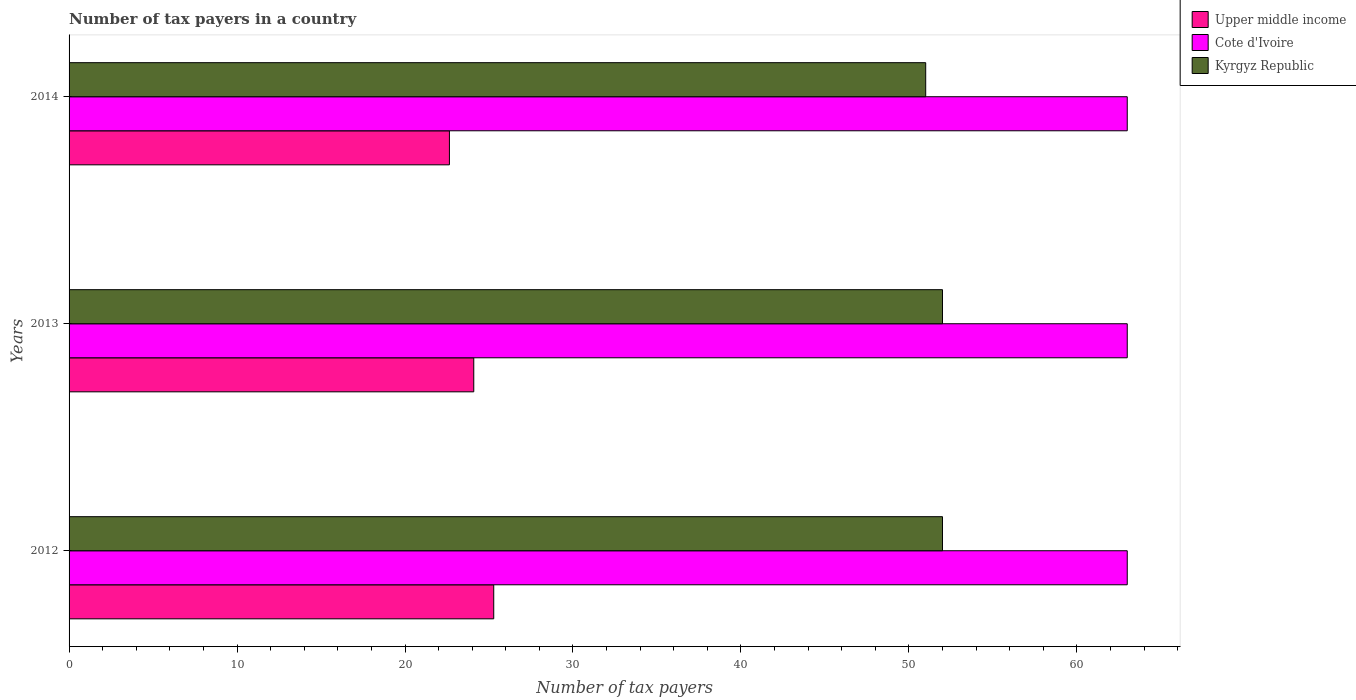How many bars are there on the 3rd tick from the top?
Offer a very short reply. 3. How many bars are there on the 1st tick from the bottom?
Give a very brief answer. 3. What is the label of the 1st group of bars from the top?
Make the answer very short. 2014. What is the number of tax payers in in Cote d'Ivoire in 2014?
Keep it short and to the point. 63. Across all years, what is the maximum number of tax payers in in Kyrgyz Republic?
Provide a succinct answer. 52. Across all years, what is the minimum number of tax payers in in Cote d'Ivoire?
Make the answer very short. 63. In which year was the number of tax payers in in Cote d'Ivoire maximum?
Provide a succinct answer. 2012. In which year was the number of tax payers in in Kyrgyz Republic minimum?
Make the answer very short. 2014. What is the total number of tax payers in in Upper middle income in the graph?
Provide a succinct answer. 72.02. What is the difference between the number of tax payers in in Kyrgyz Republic in 2013 and that in 2014?
Your answer should be compact. 1. What is the difference between the number of tax payers in in Cote d'Ivoire in 2014 and the number of tax payers in in Kyrgyz Republic in 2012?
Offer a very short reply. 11. What is the average number of tax payers in in Upper middle income per year?
Your answer should be very brief. 24.01. In the year 2012, what is the difference between the number of tax payers in in Kyrgyz Republic and number of tax payers in in Cote d'Ivoire?
Offer a very short reply. -11. What is the ratio of the number of tax payers in in Kyrgyz Republic in 2012 to that in 2013?
Your response must be concise. 1. Is the number of tax payers in in Cote d'Ivoire in 2012 less than that in 2013?
Your answer should be very brief. No. What is the difference between the highest and the second highest number of tax payers in in Cote d'Ivoire?
Make the answer very short. 0. In how many years, is the number of tax payers in in Kyrgyz Republic greater than the average number of tax payers in in Kyrgyz Republic taken over all years?
Provide a succinct answer. 2. What does the 2nd bar from the top in 2013 represents?
Give a very brief answer. Cote d'Ivoire. What does the 3rd bar from the bottom in 2014 represents?
Your response must be concise. Kyrgyz Republic. Is it the case that in every year, the sum of the number of tax payers in in Upper middle income and number of tax payers in in Kyrgyz Republic is greater than the number of tax payers in in Cote d'Ivoire?
Provide a short and direct response. Yes. How many bars are there?
Your answer should be compact. 9. How many legend labels are there?
Your answer should be compact. 3. How are the legend labels stacked?
Keep it short and to the point. Vertical. What is the title of the graph?
Keep it short and to the point. Number of tax payers in a country. Does "Slovak Republic" appear as one of the legend labels in the graph?
Offer a terse response. No. What is the label or title of the X-axis?
Your answer should be very brief. Number of tax payers. What is the label or title of the Y-axis?
Make the answer very short. Years. What is the Number of tax payers in Upper middle income in 2012?
Make the answer very short. 25.28. What is the Number of tax payers of Cote d'Ivoire in 2012?
Your answer should be very brief. 63. What is the Number of tax payers of Upper middle income in 2013?
Provide a short and direct response. 24.09. What is the Number of tax payers of Cote d'Ivoire in 2013?
Make the answer very short. 63. What is the Number of tax payers in Kyrgyz Republic in 2013?
Keep it short and to the point. 52. What is the Number of tax payers in Upper middle income in 2014?
Ensure brevity in your answer.  22.64. What is the Number of tax payers of Kyrgyz Republic in 2014?
Your response must be concise. 51. Across all years, what is the maximum Number of tax payers of Upper middle income?
Your answer should be compact. 25.28. Across all years, what is the minimum Number of tax payers in Upper middle income?
Offer a terse response. 22.64. Across all years, what is the minimum Number of tax payers in Cote d'Ivoire?
Your answer should be compact. 63. What is the total Number of tax payers in Upper middle income in the graph?
Your answer should be compact. 72.02. What is the total Number of tax payers in Cote d'Ivoire in the graph?
Offer a terse response. 189. What is the total Number of tax payers of Kyrgyz Republic in the graph?
Provide a short and direct response. 155. What is the difference between the Number of tax payers of Upper middle income in 2012 and that in 2013?
Keep it short and to the point. 1.19. What is the difference between the Number of tax payers in Kyrgyz Republic in 2012 and that in 2013?
Make the answer very short. 0. What is the difference between the Number of tax payers in Upper middle income in 2012 and that in 2014?
Your answer should be compact. 2.64. What is the difference between the Number of tax payers in Kyrgyz Republic in 2012 and that in 2014?
Give a very brief answer. 1. What is the difference between the Number of tax payers of Upper middle income in 2013 and that in 2014?
Provide a succinct answer. 1.45. What is the difference between the Number of tax payers of Upper middle income in 2012 and the Number of tax payers of Cote d'Ivoire in 2013?
Your response must be concise. -37.72. What is the difference between the Number of tax payers in Upper middle income in 2012 and the Number of tax payers in Kyrgyz Republic in 2013?
Offer a very short reply. -26.72. What is the difference between the Number of tax payers in Cote d'Ivoire in 2012 and the Number of tax payers in Kyrgyz Republic in 2013?
Give a very brief answer. 11. What is the difference between the Number of tax payers of Upper middle income in 2012 and the Number of tax payers of Cote d'Ivoire in 2014?
Make the answer very short. -37.72. What is the difference between the Number of tax payers in Upper middle income in 2012 and the Number of tax payers in Kyrgyz Republic in 2014?
Your response must be concise. -25.72. What is the difference between the Number of tax payers in Cote d'Ivoire in 2012 and the Number of tax payers in Kyrgyz Republic in 2014?
Your answer should be very brief. 12. What is the difference between the Number of tax payers in Upper middle income in 2013 and the Number of tax payers in Cote d'Ivoire in 2014?
Keep it short and to the point. -38.91. What is the difference between the Number of tax payers in Upper middle income in 2013 and the Number of tax payers in Kyrgyz Republic in 2014?
Your answer should be compact. -26.91. What is the difference between the Number of tax payers of Cote d'Ivoire in 2013 and the Number of tax payers of Kyrgyz Republic in 2014?
Your answer should be very brief. 12. What is the average Number of tax payers in Upper middle income per year?
Your answer should be very brief. 24.01. What is the average Number of tax payers in Cote d'Ivoire per year?
Your response must be concise. 63. What is the average Number of tax payers of Kyrgyz Republic per year?
Provide a short and direct response. 51.67. In the year 2012, what is the difference between the Number of tax payers in Upper middle income and Number of tax payers in Cote d'Ivoire?
Provide a succinct answer. -37.72. In the year 2012, what is the difference between the Number of tax payers in Upper middle income and Number of tax payers in Kyrgyz Republic?
Keep it short and to the point. -26.72. In the year 2012, what is the difference between the Number of tax payers in Cote d'Ivoire and Number of tax payers in Kyrgyz Republic?
Offer a very short reply. 11. In the year 2013, what is the difference between the Number of tax payers of Upper middle income and Number of tax payers of Cote d'Ivoire?
Ensure brevity in your answer.  -38.91. In the year 2013, what is the difference between the Number of tax payers of Upper middle income and Number of tax payers of Kyrgyz Republic?
Provide a succinct answer. -27.91. In the year 2013, what is the difference between the Number of tax payers of Cote d'Ivoire and Number of tax payers of Kyrgyz Republic?
Ensure brevity in your answer.  11. In the year 2014, what is the difference between the Number of tax payers of Upper middle income and Number of tax payers of Cote d'Ivoire?
Keep it short and to the point. -40.36. In the year 2014, what is the difference between the Number of tax payers in Upper middle income and Number of tax payers in Kyrgyz Republic?
Your answer should be compact. -28.36. In the year 2014, what is the difference between the Number of tax payers in Cote d'Ivoire and Number of tax payers in Kyrgyz Republic?
Keep it short and to the point. 12. What is the ratio of the Number of tax payers of Upper middle income in 2012 to that in 2013?
Ensure brevity in your answer.  1.05. What is the ratio of the Number of tax payers in Cote d'Ivoire in 2012 to that in 2013?
Your response must be concise. 1. What is the ratio of the Number of tax payers of Upper middle income in 2012 to that in 2014?
Offer a terse response. 1.12. What is the ratio of the Number of tax payers of Cote d'Ivoire in 2012 to that in 2014?
Your answer should be very brief. 1. What is the ratio of the Number of tax payers in Kyrgyz Republic in 2012 to that in 2014?
Your answer should be compact. 1.02. What is the ratio of the Number of tax payers in Upper middle income in 2013 to that in 2014?
Make the answer very short. 1.06. What is the ratio of the Number of tax payers in Kyrgyz Republic in 2013 to that in 2014?
Give a very brief answer. 1.02. What is the difference between the highest and the second highest Number of tax payers in Upper middle income?
Offer a terse response. 1.19. What is the difference between the highest and the second highest Number of tax payers in Cote d'Ivoire?
Provide a short and direct response. 0. What is the difference between the highest and the second highest Number of tax payers in Kyrgyz Republic?
Offer a very short reply. 0. What is the difference between the highest and the lowest Number of tax payers of Upper middle income?
Ensure brevity in your answer.  2.64. What is the difference between the highest and the lowest Number of tax payers in Kyrgyz Republic?
Offer a very short reply. 1. 